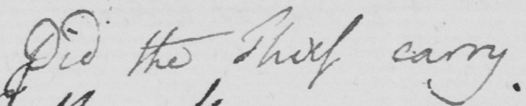What is written in this line of handwriting? Did the Thief carry 